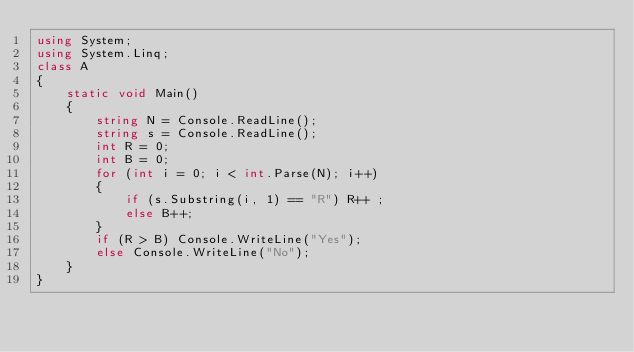Convert code to text. <code><loc_0><loc_0><loc_500><loc_500><_C#_>using System;
using System.Linq;
class A
{
    static void Main()
    {
        string N = Console.ReadLine();
        string s = Console.ReadLine();
        int R = 0;
        int B = 0;
        for (int i = 0; i < int.Parse(N); i++)
        {
            if (s.Substring(i, 1) == "R") R++ ;
            else B++;
        }
        if (R > B) Console.WriteLine("Yes");
        else Console.WriteLine("No");
    }
}</code> 